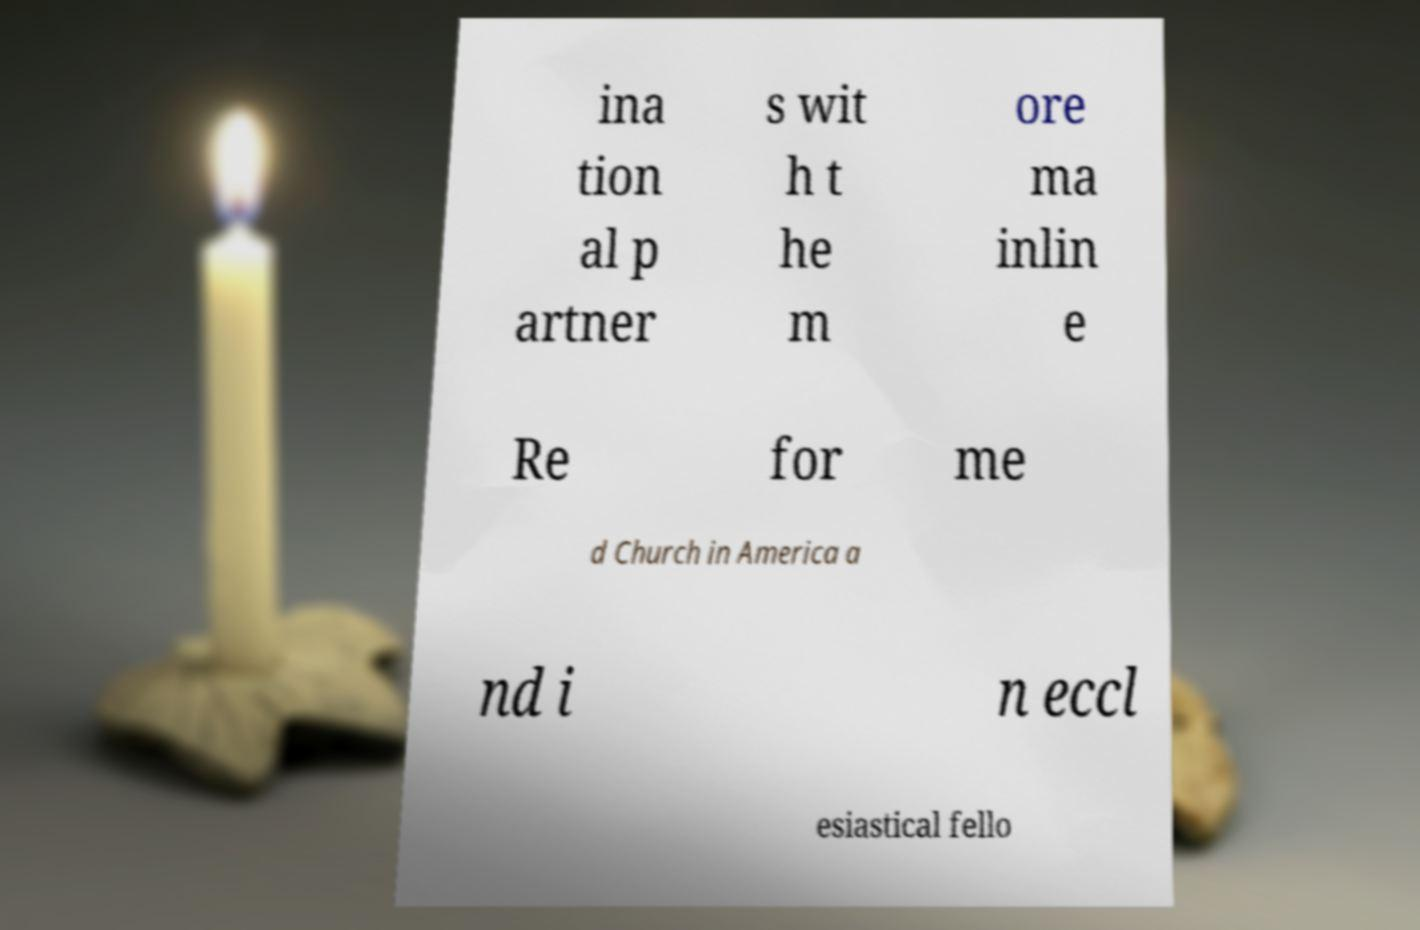Can you read and provide the text displayed in the image?This photo seems to have some interesting text. Can you extract and type it out for me? ina tion al p artner s wit h t he m ore ma inlin e Re for me d Church in America a nd i n eccl esiastical fello 